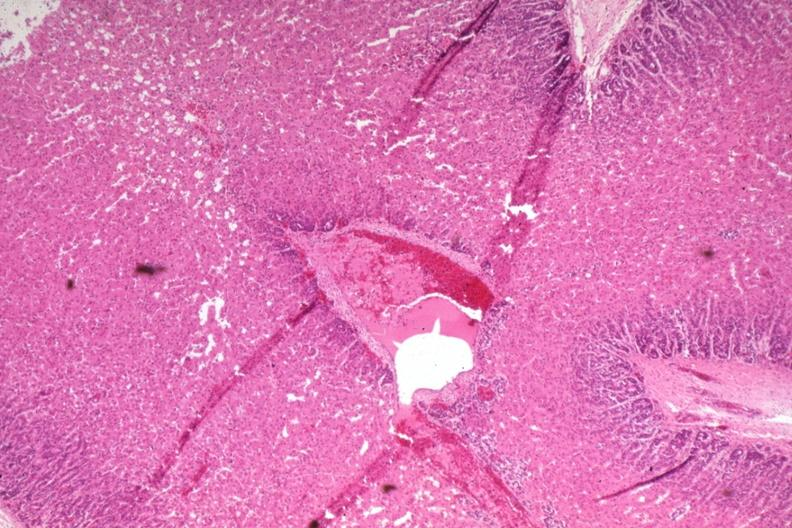what is present?
Answer the question using a single word or phrase. Endocrine 